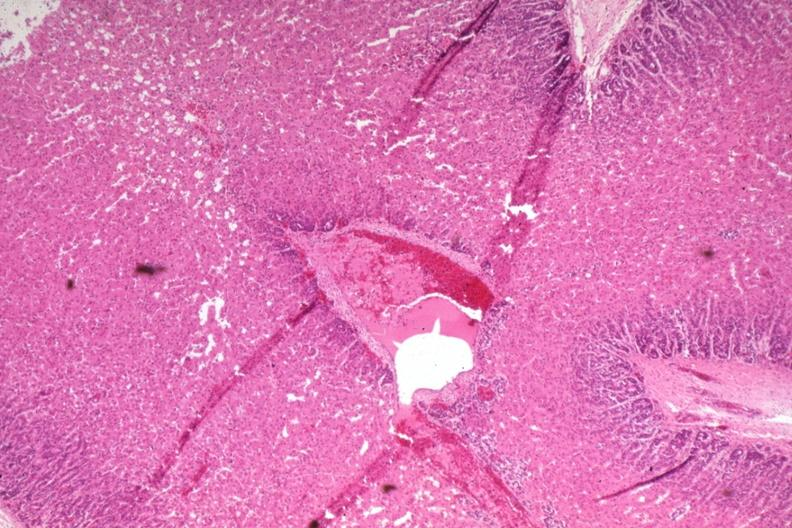what is present?
Answer the question using a single word or phrase. Endocrine 